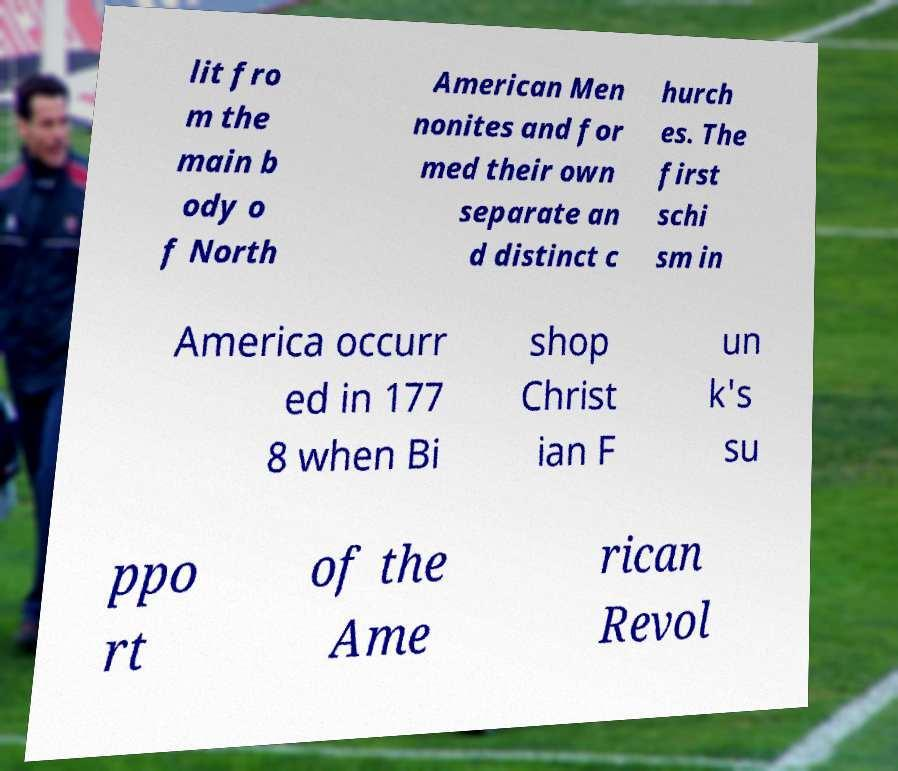Please identify and transcribe the text found in this image. lit fro m the main b ody o f North American Men nonites and for med their own separate an d distinct c hurch es. The first schi sm in America occurr ed in 177 8 when Bi shop Christ ian F un k's su ppo rt of the Ame rican Revol 